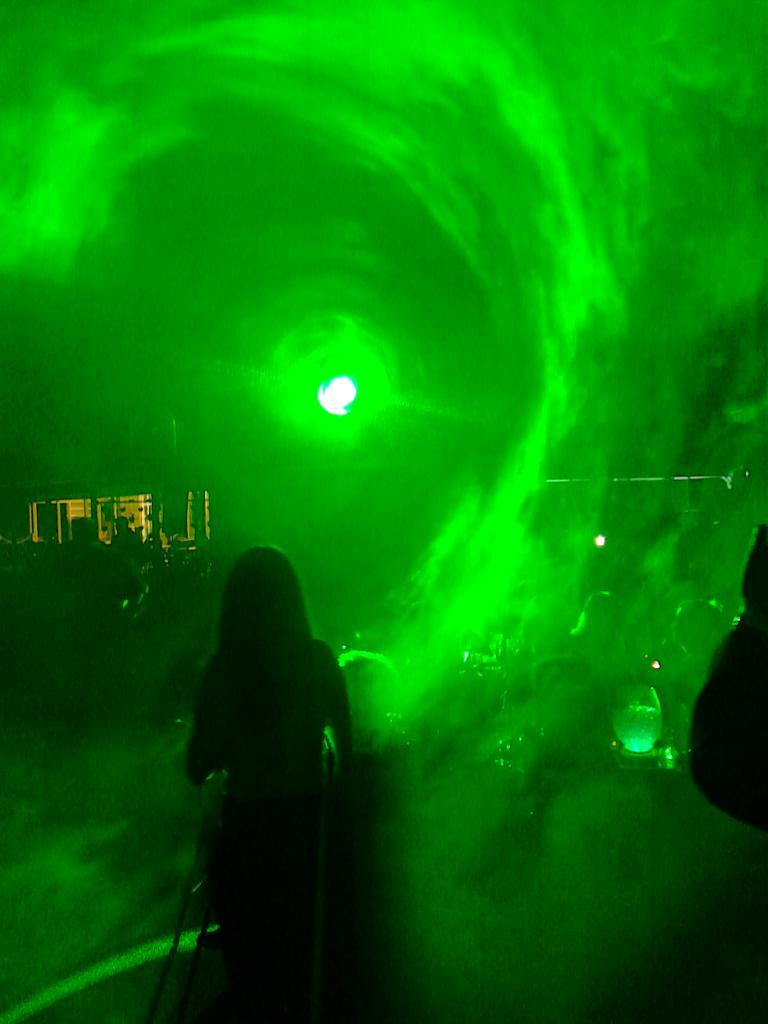What is the main subject of the image? There is a woman standing in the image. Can you describe the background of the image? There is a green light in the background of the image. What type of cup is being exchanged between the woman and the person in the image? There is no person or cup present in the image; it only features a woman standing and a green light in the background. How does the woman show respect to the person in the image? There is no person present in the image for the woman to show respect to. 